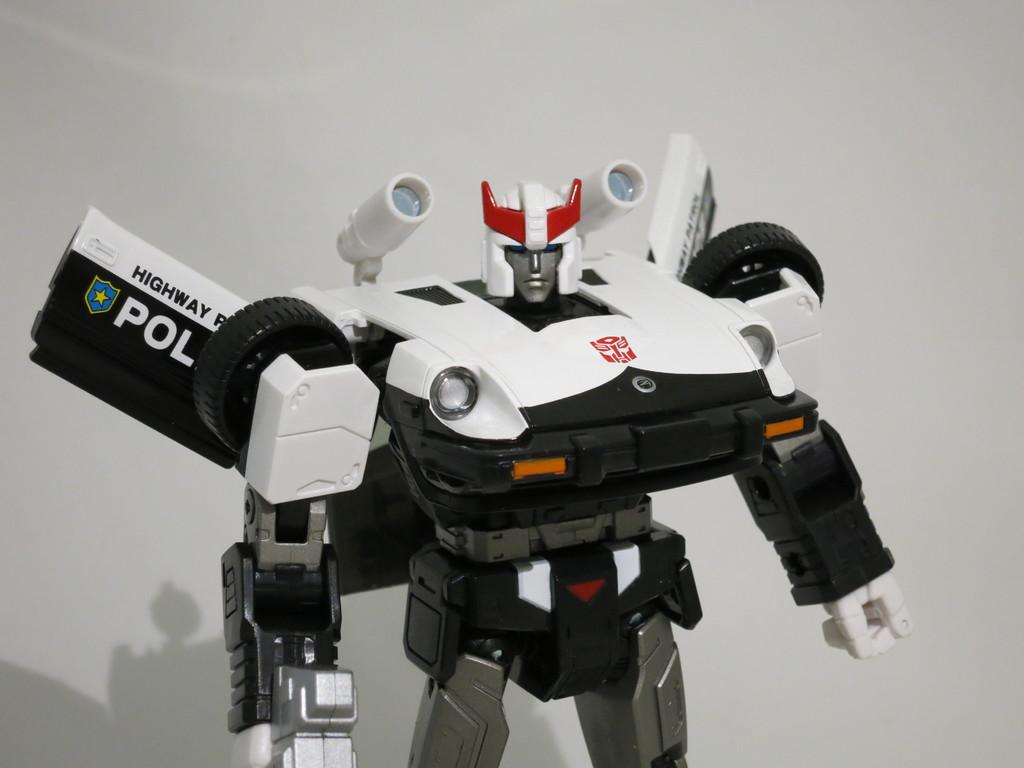Provide a one-sentence caption for the provided image. white and black robot toy that reads highway patrol. 